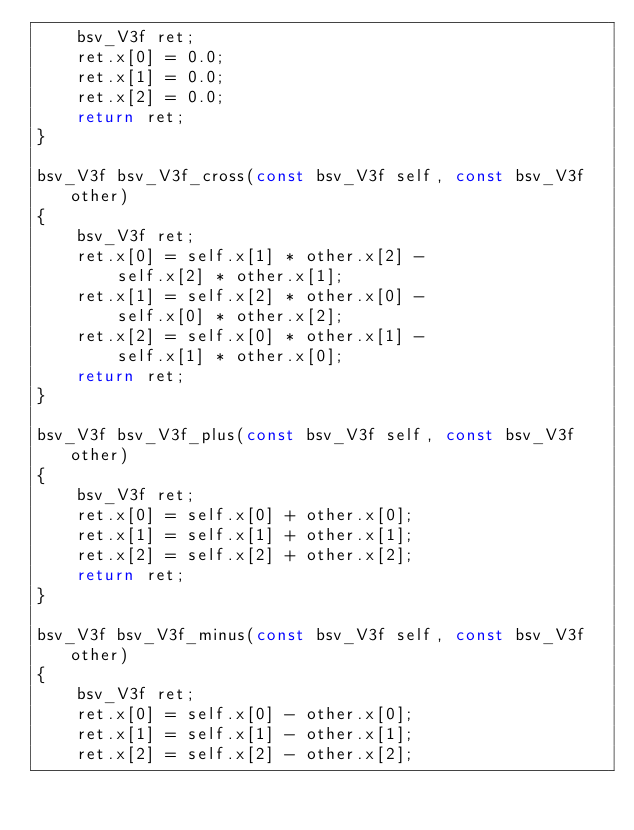Convert code to text. <code><loc_0><loc_0><loc_500><loc_500><_C_>	bsv_V3f ret;
	ret.x[0] = 0.0;
	ret.x[1] = 0.0;
	ret.x[2] = 0.0;
	return ret;
}

bsv_V3f bsv_V3f_cross(const bsv_V3f self, const bsv_V3f other)
{
	bsv_V3f ret;
	ret.x[0] = self.x[1] * other.x[2] -
		self.x[2] * other.x[1];
	ret.x[1] = self.x[2] * other.x[0] -
		self.x[0] * other.x[2];
	ret.x[2] = self.x[0] * other.x[1] -
		self.x[1] * other.x[0];
	return ret;
}

bsv_V3f bsv_V3f_plus(const bsv_V3f self, const bsv_V3f other)
{
	bsv_V3f ret;
	ret.x[0] = self.x[0] + other.x[0];
	ret.x[1] = self.x[1] + other.x[1];
	ret.x[2] = self.x[2] + other.x[2];
	return ret;
}

bsv_V3f bsv_V3f_minus(const bsv_V3f self, const bsv_V3f other)
{
	bsv_V3f ret;
	ret.x[0] = self.x[0] - other.x[0];
	ret.x[1] = self.x[1] - other.x[1];
	ret.x[2] = self.x[2] - other.x[2];</code> 